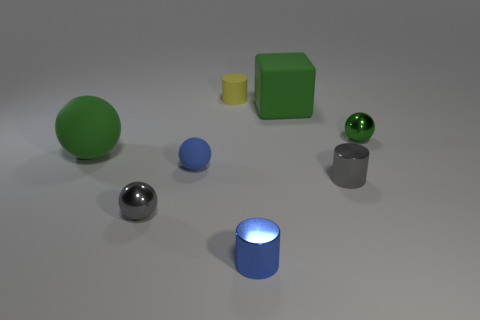Subtract all small spheres. How many spheres are left? 1 Add 7 big green metal blocks. How many big green metal blocks exist? 7 Add 2 big cubes. How many objects exist? 10 Subtract all gray spheres. How many spheres are left? 3 Subtract 0 red blocks. How many objects are left? 8 Subtract all cylinders. How many objects are left? 5 Subtract 2 cylinders. How many cylinders are left? 1 Subtract all blue cylinders. Subtract all green cubes. How many cylinders are left? 2 Subtract all green cylinders. How many purple balls are left? 0 Subtract all green things. Subtract all tiny yellow cylinders. How many objects are left? 4 